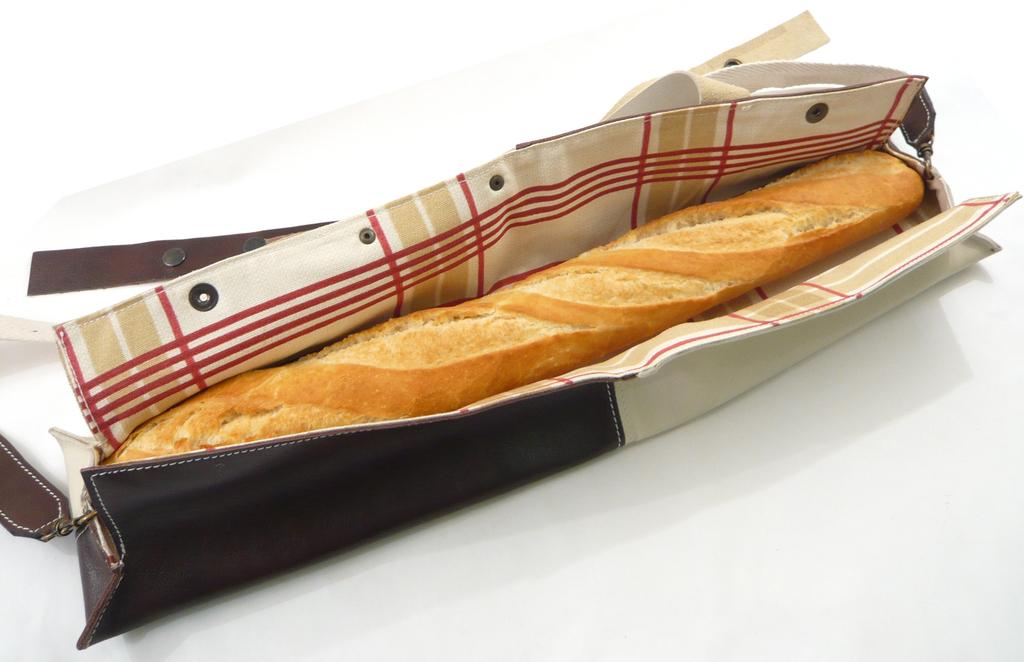What is the main subject of the image? There is a food item in the image. How is the food item contained or packaged? The food item is in a bag. What color is the background of the image? The background of the image is white. Can you hear the sound of the food item in the image? The image is a visual representation and does not contain any audible information, so it is not possible to hear the sound of the food item in the image. 